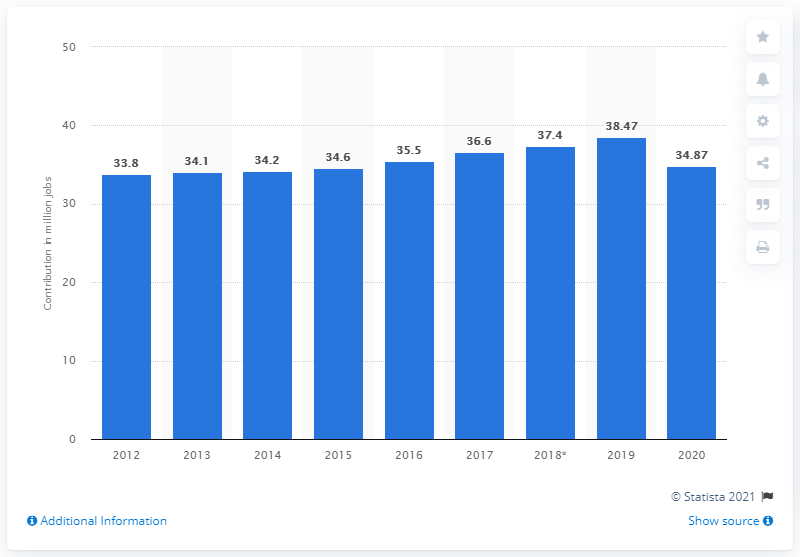Mention a couple of crucial points in this snapshot. In 2019, the total number of jobs contributed by travel and tourism in Europe was 38.47 million. In 2020, the travel and tourism industry generated approximately 34,870 jobs. 